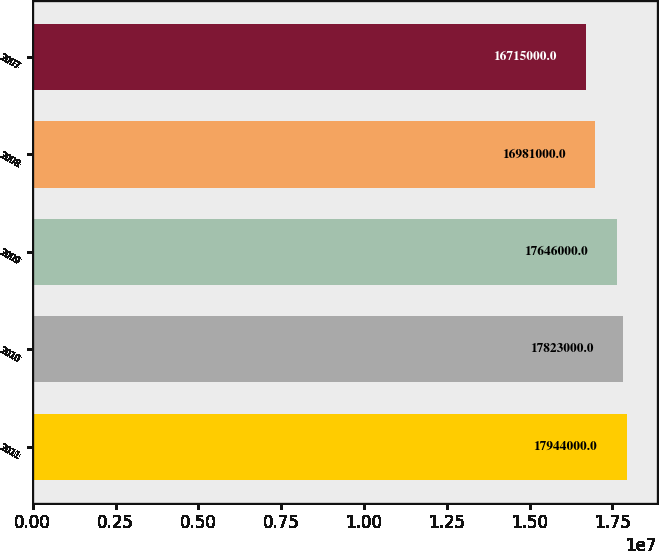Convert chart to OTSL. <chart><loc_0><loc_0><loc_500><loc_500><bar_chart><fcel>2011<fcel>2010<fcel>2009<fcel>2008<fcel>2007<nl><fcel>1.7944e+07<fcel>1.7823e+07<fcel>1.7646e+07<fcel>1.6981e+07<fcel>1.6715e+07<nl></chart> 